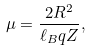<formula> <loc_0><loc_0><loc_500><loc_500>\mu = \frac { 2 R ^ { 2 } } { \ell _ { B } q Z } ,</formula> 